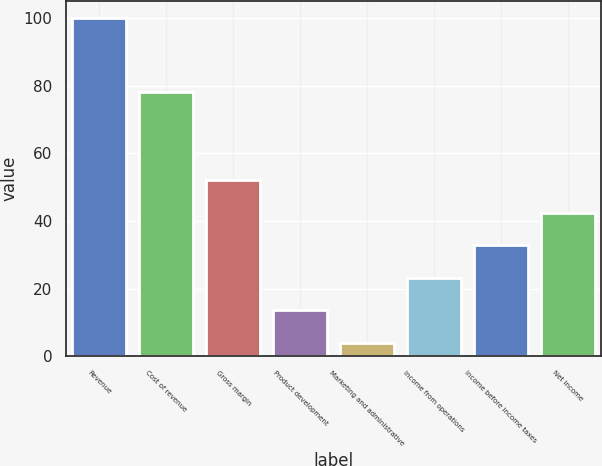<chart> <loc_0><loc_0><loc_500><loc_500><bar_chart><fcel>Revenue<fcel>Cost of revenue<fcel>Gross margin<fcel>Product development<fcel>Marketing and administrative<fcel>Income from operations<fcel>Income before income taxes<fcel>Net income<nl><fcel>100<fcel>78<fcel>52<fcel>13.6<fcel>4<fcel>23.2<fcel>32.8<fcel>42.4<nl></chart> 